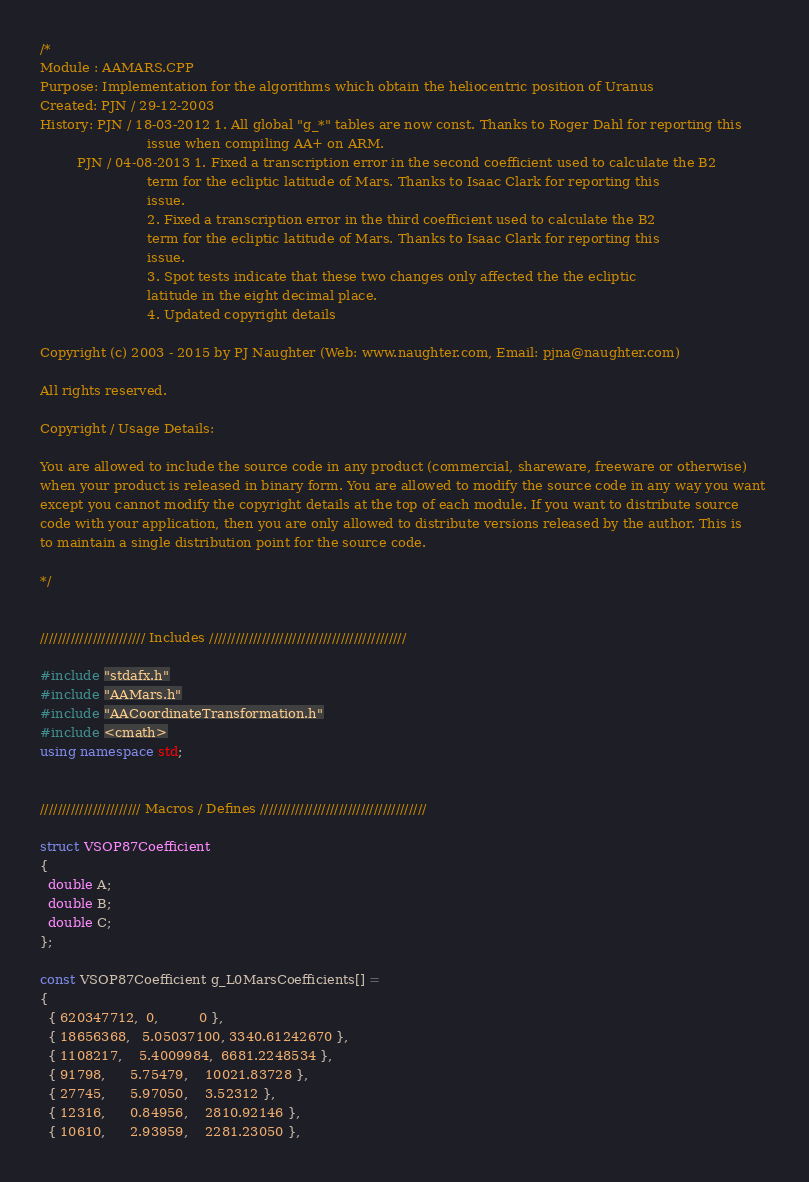<code> <loc_0><loc_0><loc_500><loc_500><_C++_>/*
Module : AAMARS.CPP
Purpose: Implementation for the algorithms which obtain the heliocentric position of Uranus
Created: PJN / 29-12-2003
History: PJN / 18-03-2012 1. All global "g_*" tables are now const. Thanks to Roger Dahl for reporting this 
                          issue when compiling AA+ on ARM.
         PJN / 04-08-2013 1. Fixed a transcription error in the second coefficient used to calculate the B2 
                          term for the ecliptic latitude of Mars. Thanks to Isaac Clark for reporting this 
                          issue.
                          2. Fixed a transcription error in the third coefficient used to calculate the B2 
                          term for the ecliptic latitude of Mars. Thanks to Isaac Clark for reporting this 
                          issue. 
                          3. Spot tests indicate that these two changes only affected the the ecliptic 
                          latitude in the eight decimal place.
                          4. Updated copyright details

Copyright (c) 2003 - 2015 by PJ Naughter (Web: www.naughter.com, Email: pjna@naughter.com)

All rights reserved.

Copyright / Usage Details:

You are allowed to include the source code in any product (commercial, shareware, freeware or otherwise) 
when your product is released in binary form. You are allowed to modify the source code in any way you want 
except you cannot modify the copyright details at the top of each module. If you want to distribute source 
code with your application, then you are only allowed to distribute versions released by the author. This is 
to maintain a single distribution point for the source code. 

*/


//////////////////////// Includes /////////////////////////////////////////////

#include "stdafx.h"
#include "AAMars.h"
#include "AACoordinateTransformation.h"
#include <cmath>
using namespace std;


/////////////////////// Macros / Defines //////////////////////////////////////

struct VSOP87Coefficient
{
  double A;
  double B;
  double C;
};

const VSOP87Coefficient g_L0MarsCoefficients[] =
{ 
  { 620347712,  0,          0 },
  { 18656368,   5.05037100, 3340.61242670 },
  { 1108217,    5.4009984,  6681.2248534 },
  { 91798,      5.75479,    10021.83728 },
  { 27745,      5.97050,    3.52312 },
  { 12316,      0.84956,    2810.92146 },
  { 10610,      2.93959,    2281.23050 },</code> 